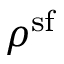<formula> <loc_0><loc_0><loc_500><loc_500>\rho ^ { s f }</formula> 